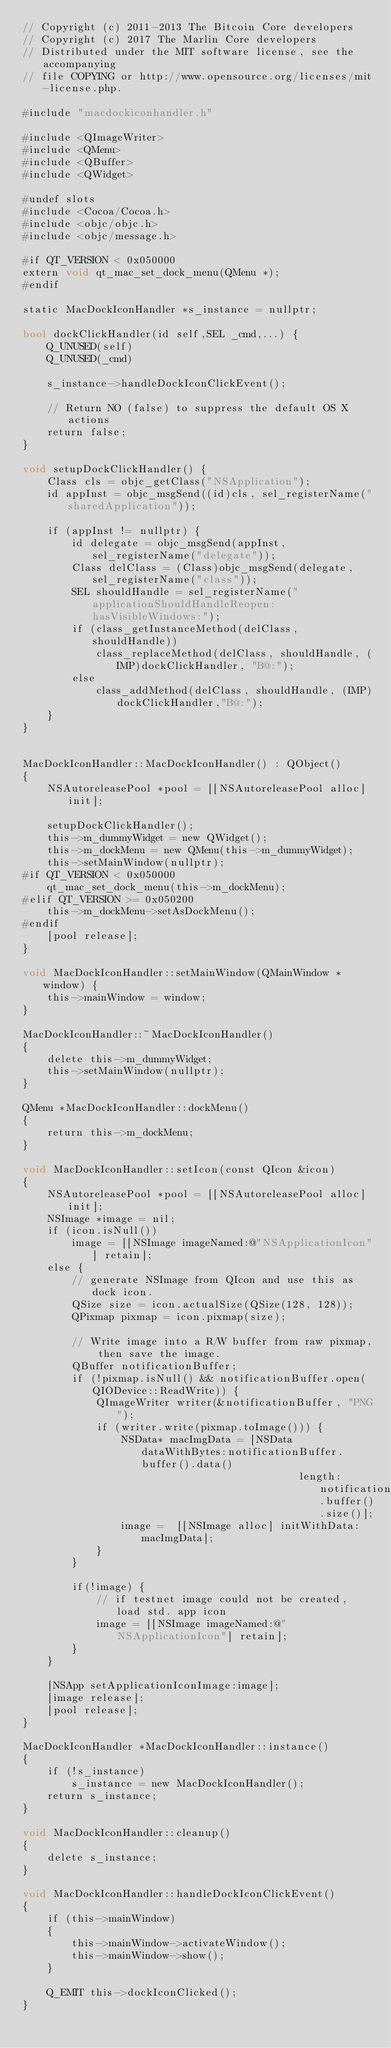<code> <loc_0><loc_0><loc_500><loc_500><_ObjectiveC_>// Copyright (c) 2011-2013 The Bitcoin Core developers
// Copyright (c) 2017 The Marlin Core developers
// Distributed under the MIT software license, see the accompanying
// file COPYING or http://www.opensource.org/licenses/mit-license.php.

#include "macdockiconhandler.h"

#include <QImageWriter>
#include <QMenu>
#include <QBuffer>
#include <QWidget>

#undef slots
#include <Cocoa/Cocoa.h>
#include <objc/objc.h>
#include <objc/message.h>

#if QT_VERSION < 0x050000
extern void qt_mac_set_dock_menu(QMenu *);
#endif

static MacDockIconHandler *s_instance = nullptr;

bool dockClickHandler(id self,SEL _cmd,...) {
    Q_UNUSED(self)
    Q_UNUSED(_cmd)
    
    s_instance->handleDockIconClickEvent();
    
    // Return NO (false) to suppress the default OS X actions
    return false;
}

void setupDockClickHandler() {
    Class cls = objc_getClass("NSApplication");
    id appInst = objc_msgSend((id)cls, sel_registerName("sharedApplication"));
    
    if (appInst != nullptr) {
        id delegate = objc_msgSend(appInst, sel_registerName("delegate"));
        Class delClass = (Class)objc_msgSend(delegate,  sel_registerName("class"));
        SEL shouldHandle = sel_registerName("applicationShouldHandleReopen:hasVisibleWindows:");
        if (class_getInstanceMethod(delClass, shouldHandle))
            class_replaceMethod(delClass, shouldHandle, (IMP)dockClickHandler, "B@:");
        else
            class_addMethod(delClass, shouldHandle, (IMP)dockClickHandler,"B@:");
    }
}


MacDockIconHandler::MacDockIconHandler() : QObject()
{
    NSAutoreleasePool *pool = [[NSAutoreleasePool alloc] init];

    setupDockClickHandler();
    this->m_dummyWidget = new QWidget();
    this->m_dockMenu = new QMenu(this->m_dummyWidget);
    this->setMainWindow(nullptr);
#if QT_VERSION < 0x050000
    qt_mac_set_dock_menu(this->m_dockMenu);
#elif QT_VERSION >= 0x050200
    this->m_dockMenu->setAsDockMenu();
#endif
    [pool release];
}

void MacDockIconHandler::setMainWindow(QMainWindow *window) {
    this->mainWindow = window;
}

MacDockIconHandler::~MacDockIconHandler()
{
    delete this->m_dummyWidget;
    this->setMainWindow(nullptr);
}

QMenu *MacDockIconHandler::dockMenu()
{
    return this->m_dockMenu;
}

void MacDockIconHandler::setIcon(const QIcon &icon)
{
    NSAutoreleasePool *pool = [[NSAutoreleasePool alloc] init];
    NSImage *image = nil;
    if (icon.isNull())
        image = [[NSImage imageNamed:@"NSApplicationIcon"] retain];
    else {
        // generate NSImage from QIcon and use this as dock icon.
        QSize size = icon.actualSize(QSize(128, 128));
        QPixmap pixmap = icon.pixmap(size);

        // Write image into a R/W buffer from raw pixmap, then save the image.
        QBuffer notificationBuffer;
        if (!pixmap.isNull() && notificationBuffer.open(QIODevice::ReadWrite)) {
            QImageWriter writer(&notificationBuffer, "PNG");
            if (writer.write(pixmap.toImage())) {
                NSData* macImgData = [NSData dataWithBytes:notificationBuffer.buffer().data()
                                             length:notificationBuffer.buffer().size()];
                image =  [[NSImage alloc] initWithData:macImgData];
            }
        }

        if(!image) {
            // if testnet image could not be created, load std. app icon
            image = [[NSImage imageNamed:@"NSApplicationIcon"] retain];
        }
    }

    [NSApp setApplicationIconImage:image];
    [image release];
    [pool release];
}

MacDockIconHandler *MacDockIconHandler::instance()
{
    if (!s_instance)
        s_instance = new MacDockIconHandler();
    return s_instance;
}

void MacDockIconHandler::cleanup()
{
    delete s_instance;
}

void MacDockIconHandler::handleDockIconClickEvent()
{
    if (this->mainWindow)
    {
        this->mainWindow->activateWindow();
        this->mainWindow->show();
    }

    Q_EMIT this->dockIconClicked();
}
</code> 